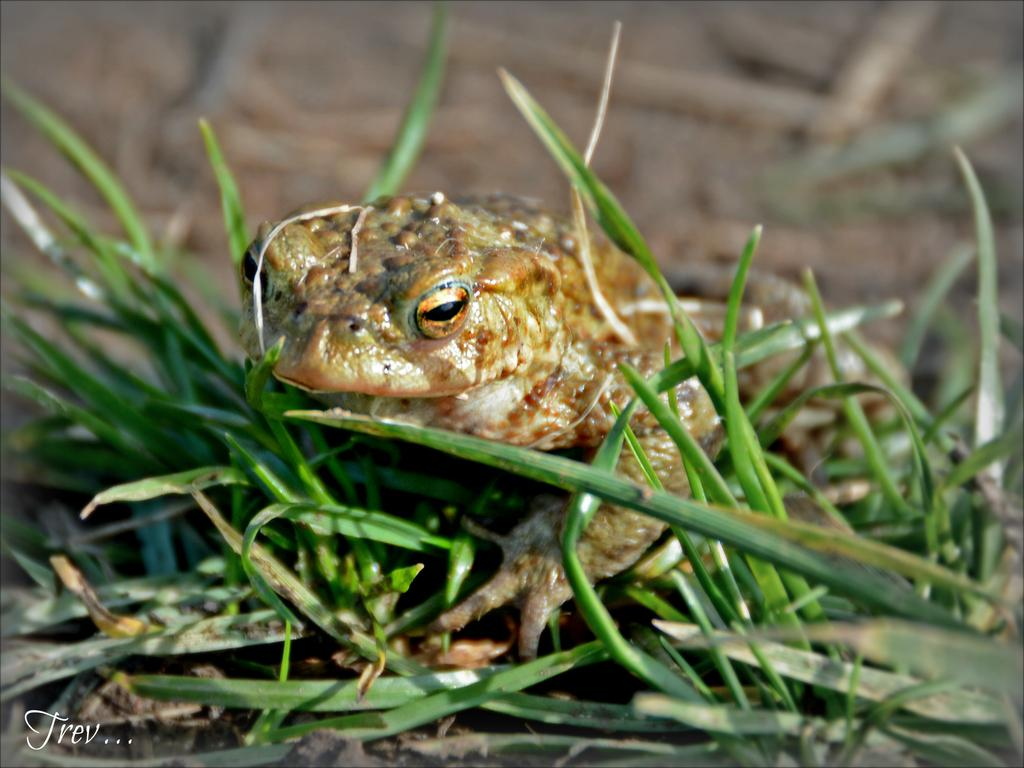What animal is present in the image? There is a frog in the picture. What type of vegetation can be seen in the image? There is grass in the picture. How would you describe the background of the image? The background of the image is blurred. Where is the text located in the image? The text is in the bottom left corner of the image. What language is the frog speaking at the party in the hall? There is no party or hall present in the image, and the frog is not speaking any language. 